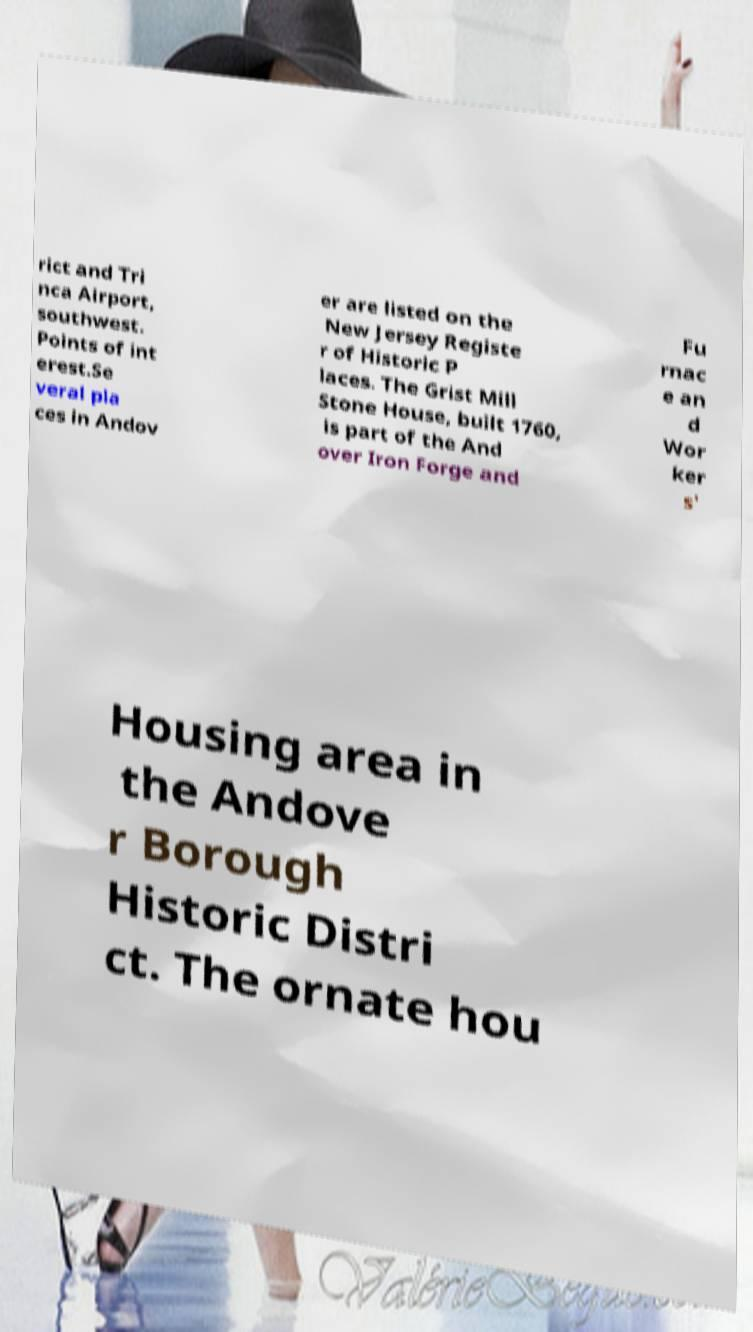What messages or text are displayed in this image? I need them in a readable, typed format. rict and Tri nca Airport, southwest. Points of int erest.Se veral pla ces in Andov er are listed on the New Jersey Registe r of Historic P laces. The Grist Mill Stone House, built 1760, is part of the And over Iron Forge and Fu rnac e an d Wor ker s' Housing area in the Andove r Borough Historic Distri ct. The ornate hou 